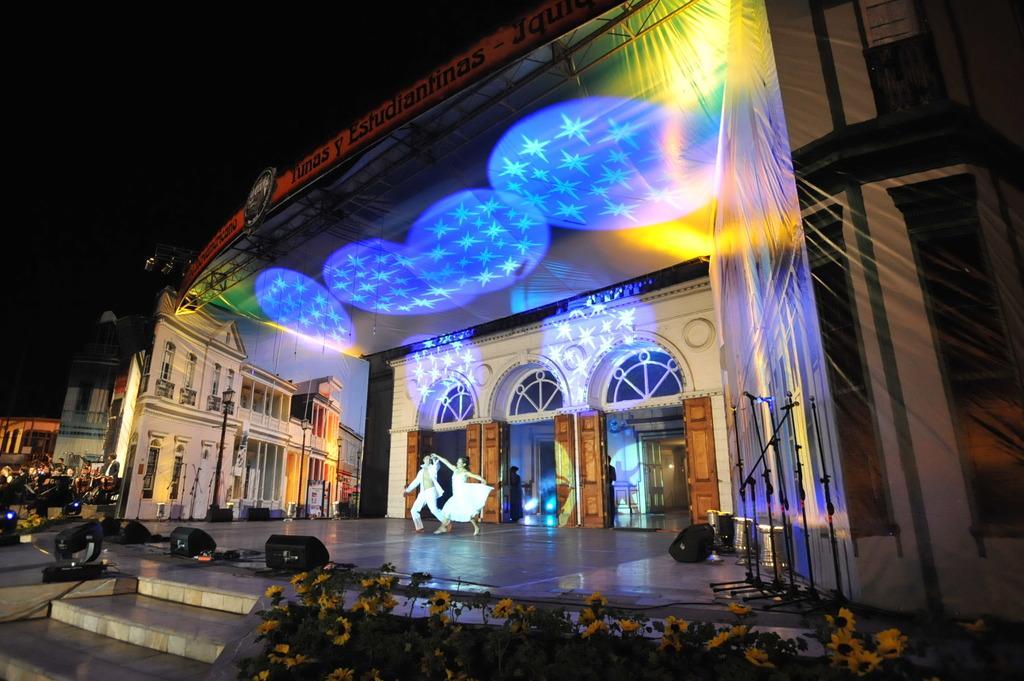Could you give a brief overview of what you see in this image? At the bottom of the image we can see plants with flowers. In the center of the image we can see a stage. On the stage, we can see two persons are performing and we can see a few other objects. In the background, we can see buildings and a few people. 